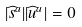<formula> <loc_0><loc_0><loc_500><loc_500>| \widehat { s } ^ { a } | | \widehat { u } ^ { a } | = 0</formula> 